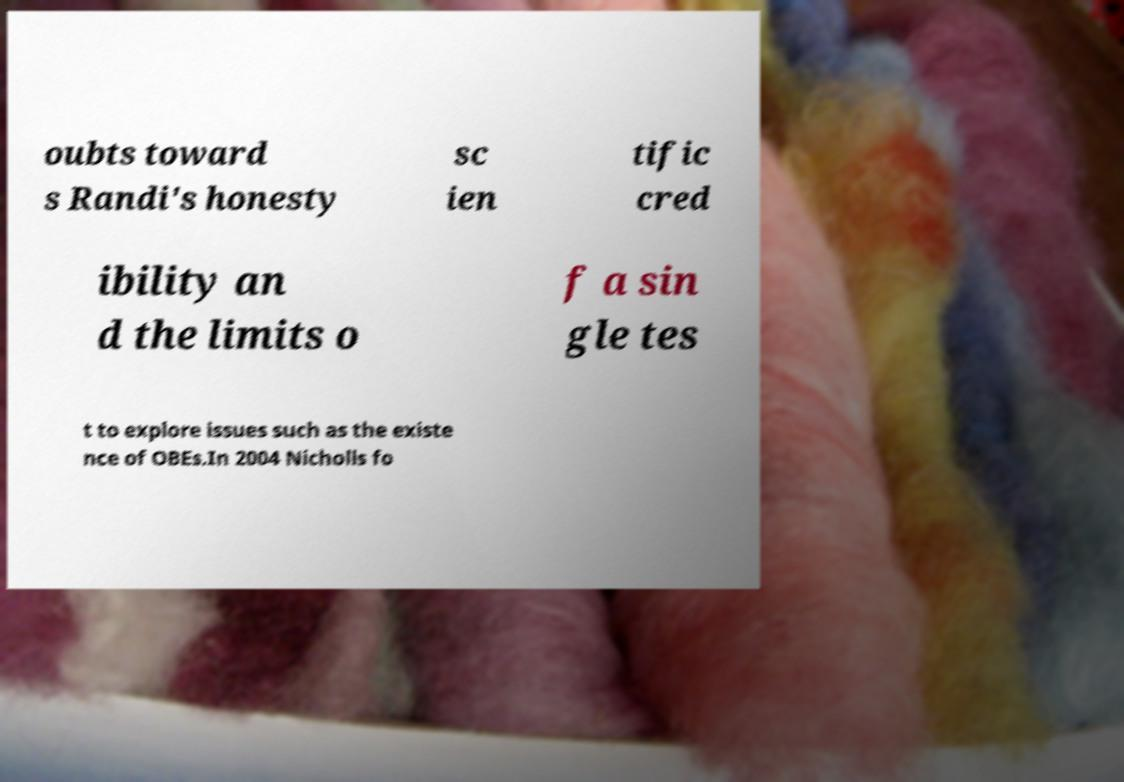I need the written content from this picture converted into text. Can you do that? oubts toward s Randi's honesty sc ien tific cred ibility an d the limits o f a sin gle tes t to explore issues such as the existe nce of OBEs.In 2004 Nicholls fo 